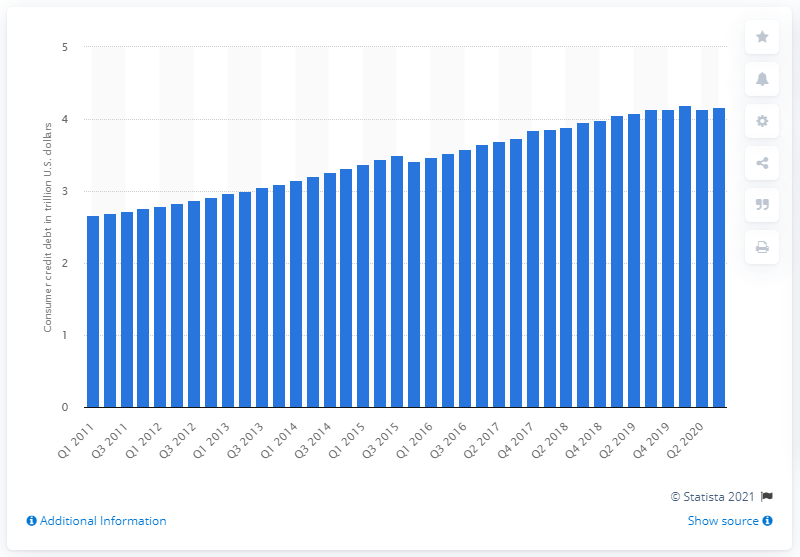Outline some significant characteristics in this image. The consumer credit debt of households and nonprofit organizations in the third quarter of 2020 was $4.16 trillion. 